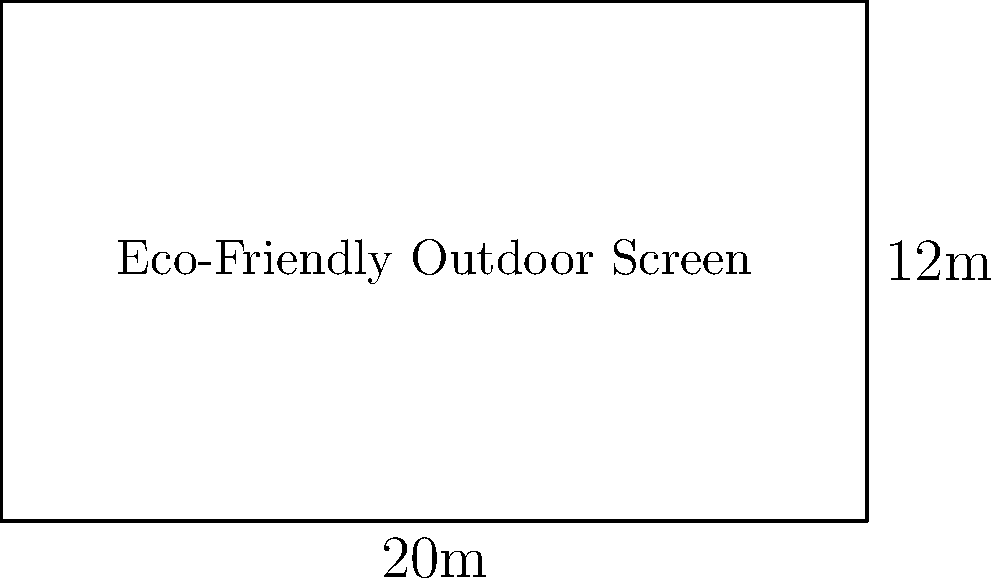An eco-friendly outdoor movie screen is being set up for a film festival showcasing environmental documentaries. The rectangular screen measures 20 meters in length and 12 meters in height. What is the perimeter of the screen? To find the perimeter of the rectangular screen, we need to follow these steps:

1. Identify the formula for the perimeter of a rectangle:
   Perimeter = 2 * (length + width)

2. Substitute the given dimensions:
   Length (l) = 20 meters
   Width (w) = 12 meters

3. Apply the formula:
   Perimeter = 2 * (20 + 12)
   
4. Perform the calculation:
   Perimeter = 2 * 32
   Perimeter = 64 meters

Therefore, the perimeter of the eco-friendly outdoor movie screen is 64 meters.
Answer: 64 meters 